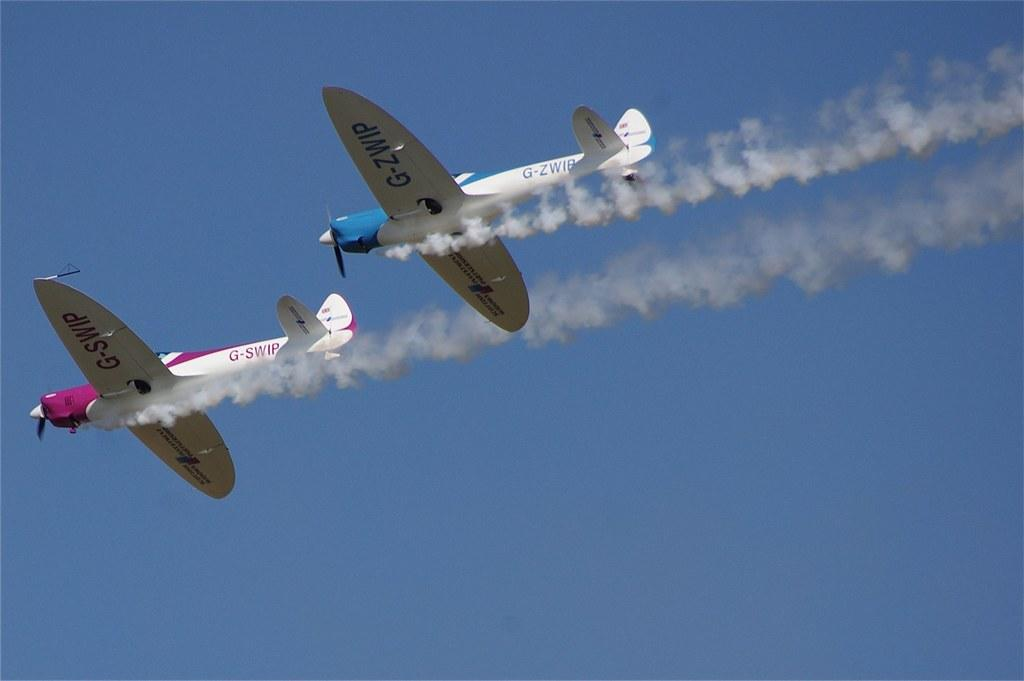What is the main subject of the image? The main subject of the image is two jet planes. What are the jet planes doing in the image? The jet planes are flying in the sky. What else can be seen in the image besides the jet planes? There is smoke visible in the image. What type of copper material can be seen on the jet planes in the image? There is no copper material present on the jet planes in the image. How quiet are the jet planes flying in the image? The noise level of the jet planes cannot be determined from the image alone. 